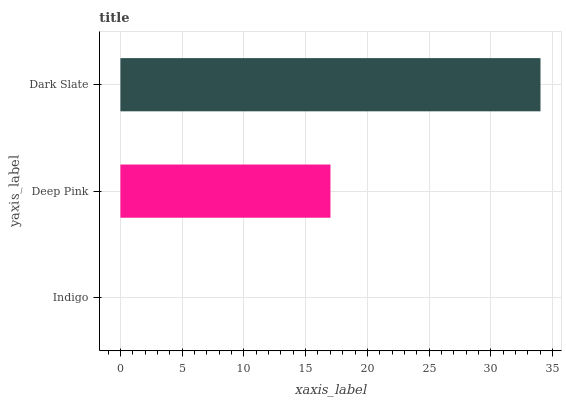Is Indigo the minimum?
Answer yes or no. Yes. Is Dark Slate the maximum?
Answer yes or no. Yes. Is Deep Pink the minimum?
Answer yes or no. No. Is Deep Pink the maximum?
Answer yes or no. No. Is Deep Pink greater than Indigo?
Answer yes or no. Yes. Is Indigo less than Deep Pink?
Answer yes or no. Yes. Is Indigo greater than Deep Pink?
Answer yes or no. No. Is Deep Pink less than Indigo?
Answer yes or no. No. Is Deep Pink the high median?
Answer yes or no. Yes. Is Deep Pink the low median?
Answer yes or no. Yes. Is Dark Slate the high median?
Answer yes or no. No. Is Indigo the low median?
Answer yes or no. No. 